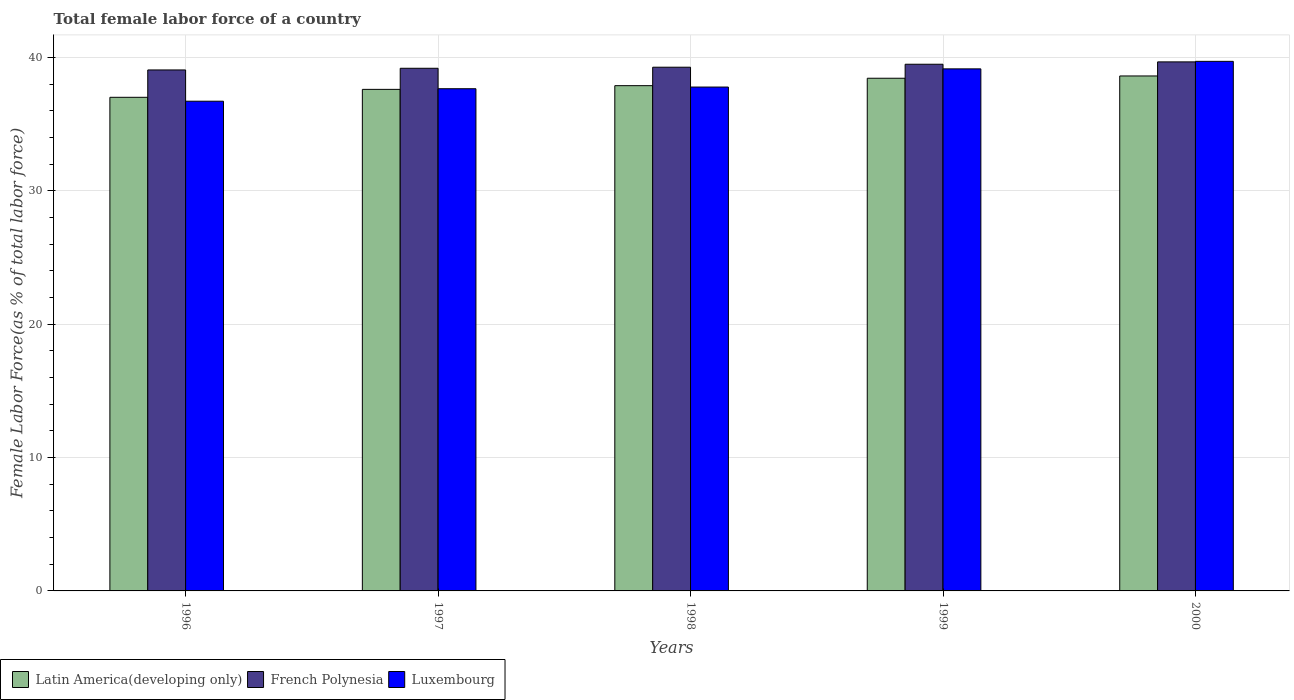How many different coloured bars are there?
Ensure brevity in your answer.  3. Are the number of bars on each tick of the X-axis equal?
Offer a very short reply. Yes. What is the percentage of female labor force in Luxembourg in 1999?
Provide a short and direct response. 39.16. Across all years, what is the maximum percentage of female labor force in French Polynesia?
Ensure brevity in your answer.  39.68. Across all years, what is the minimum percentage of female labor force in French Polynesia?
Your answer should be compact. 39.08. In which year was the percentage of female labor force in Latin America(developing only) minimum?
Offer a terse response. 1996. What is the total percentage of female labor force in French Polynesia in the graph?
Make the answer very short. 196.76. What is the difference between the percentage of female labor force in Latin America(developing only) in 1998 and that in 2000?
Make the answer very short. -0.73. What is the difference between the percentage of female labor force in French Polynesia in 1997 and the percentage of female labor force in Latin America(developing only) in 1999?
Ensure brevity in your answer.  0.75. What is the average percentage of female labor force in Luxembourg per year?
Provide a succinct answer. 38.22. In the year 1999, what is the difference between the percentage of female labor force in French Polynesia and percentage of female labor force in Luxembourg?
Ensure brevity in your answer.  0.35. What is the ratio of the percentage of female labor force in Luxembourg in 1998 to that in 2000?
Your answer should be compact. 0.95. Is the percentage of female labor force in Luxembourg in 1998 less than that in 1999?
Give a very brief answer. Yes. Is the difference between the percentage of female labor force in French Polynesia in 1997 and 1999 greater than the difference between the percentage of female labor force in Luxembourg in 1997 and 1999?
Provide a succinct answer. Yes. What is the difference between the highest and the second highest percentage of female labor force in Luxembourg?
Offer a terse response. 0.56. What is the difference between the highest and the lowest percentage of female labor force in Luxembourg?
Provide a succinct answer. 2.99. In how many years, is the percentage of female labor force in French Polynesia greater than the average percentage of female labor force in French Polynesia taken over all years?
Your response must be concise. 2. Is the sum of the percentage of female labor force in Latin America(developing only) in 1996 and 1998 greater than the maximum percentage of female labor force in French Polynesia across all years?
Your answer should be compact. Yes. What does the 2nd bar from the left in 1996 represents?
Keep it short and to the point. French Polynesia. What does the 3rd bar from the right in 1998 represents?
Make the answer very short. Latin America(developing only). How many bars are there?
Provide a short and direct response. 15. How many years are there in the graph?
Offer a very short reply. 5. Are the values on the major ticks of Y-axis written in scientific E-notation?
Provide a succinct answer. No. How many legend labels are there?
Offer a very short reply. 3. What is the title of the graph?
Give a very brief answer. Total female labor force of a country. Does "Aruba" appear as one of the legend labels in the graph?
Your response must be concise. No. What is the label or title of the X-axis?
Give a very brief answer. Years. What is the label or title of the Y-axis?
Keep it short and to the point. Female Labor Force(as % of total labor force). What is the Female Labor Force(as % of total labor force) of Latin America(developing only) in 1996?
Provide a short and direct response. 37.03. What is the Female Labor Force(as % of total labor force) of French Polynesia in 1996?
Ensure brevity in your answer.  39.08. What is the Female Labor Force(as % of total labor force) in Luxembourg in 1996?
Give a very brief answer. 36.73. What is the Female Labor Force(as % of total labor force) in Latin America(developing only) in 1997?
Ensure brevity in your answer.  37.62. What is the Female Labor Force(as % of total labor force) of French Polynesia in 1997?
Give a very brief answer. 39.2. What is the Female Labor Force(as % of total labor force) of Luxembourg in 1997?
Your answer should be very brief. 37.67. What is the Female Labor Force(as % of total labor force) of Latin America(developing only) in 1998?
Your response must be concise. 37.9. What is the Female Labor Force(as % of total labor force) of French Polynesia in 1998?
Offer a very short reply. 39.28. What is the Female Labor Force(as % of total labor force) in Luxembourg in 1998?
Make the answer very short. 37.8. What is the Female Labor Force(as % of total labor force) in Latin America(developing only) in 1999?
Provide a short and direct response. 38.46. What is the Female Labor Force(as % of total labor force) of French Polynesia in 1999?
Your answer should be compact. 39.51. What is the Female Labor Force(as % of total labor force) of Luxembourg in 1999?
Your answer should be very brief. 39.16. What is the Female Labor Force(as % of total labor force) of Latin America(developing only) in 2000?
Your answer should be very brief. 38.63. What is the Female Labor Force(as % of total labor force) of French Polynesia in 2000?
Provide a short and direct response. 39.68. What is the Female Labor Force(as % of total labor force) of Luxembourg in 2000?
Make the answer very short. 39.72. Across all years, what is the maximum Female Labor Force(as % of total labor force) of Latin America(developing only)?
Offer a terse response. 38.63. Across all years, what is the maximum Female Labor Force(as % of total labor force) in French Polynesia?
Keep it short and to the point. 39.68. Across all years, what is the maximum Female Labor Force(as % of total labor force) of Luxembourg?
Your response must be concise. 39.72. Across all years, what is the minimum Female Labor Force(as % of total labor force) of Latin America(developing only)?
Your response must be concise. 37.03. Across all years, what is the minimum Female Labor Force(as % of total labor force) of French Polynesia?
Offer a terse response. 39.08. Across all years, what is the minimum Female Labor Force(as % of total labor force) of Luxembourg?
Provide a succinct answer. 36.73. What is the total Female Labor Force(as % of total labor force) in Latin America(developing only) in the graph?
Your answer should be compact. 189.63. What is the total Female Labor Force(as % of total labor force) in French Polynesia in the graph?
Provide a short and direct response. 196.76. What is the total Female Labor Force(as % of total labor force) in Luxembourg in the graph?
Keep it short and to the point. 191.08. What is the difference between the Female Labor Force(as % of total labor force) of Latin America(developing only) in 1996 and that in 1997?
Offer a terse response. -0.6. What is the difference between the Female Labor Force(as % of total labor force) of French Polynesia in 1996 and that in 1997?
Provide a short and direct response. -0.13. What is the difference between the Female Labor Force(as % of total labor force) in Luxembourg in 1996 and that in 1997?
Your answer should be compact. -0.94. What is the difference between the Female Labor Force(as % of total labor force) of Latin America(developing only) in 1996 and that in 1998?
Make the answer very short. -0.87. What is the difference between the Female Labor Force(as % of total labor force) of French Polynesia in 1996 and that in 1998?
Offer a very short reply. -0.2. What is the difference between the Female Labor Force(as % of total labor force) of Luxembourg in 1996 and that in 1998?
Ensure brevity in your answer.  -1.06. What is the difference between the Female Labor Force(as % of total labor force) of Latin America(developing only) in 1996 and that in 1999?
Your answer should be very brief. -1.43. What is the difference between the Female Labor Force(as % of total labor force) in French Polynesia in 1996 and that in 1999?
Keep it short and to the point. -0.43. What is the difference between the Female Labor Force(as % of total labor force) in Luxembourg in 1996 and that in 1999?
Your response must be concise. -2.43. What is the difference between the Female Labor Force(as % of total labor force) in Latin America(developing only) in 1996 and that in 2000?
Make the answer very short. -1.6. What is the difference between the Female Labor Force(as % of total labor force) in French Polynesia in 1996 and that in 2000?
Your answer should be compact. -0.61. What is the difference between the Female Labor Force(as % of total labor force) of Luxembourg in 1996 and that in 2000?
Offer a terse response. -2.99. What is the difference between the Female Labor Force(as % of total labor force) of Latin America(developing only) in 1997 and that in 1998?
Give a very brief answer. -0.28. What is the difference between the Female Labor Force(as % of total labor force) in French Polynesia in 1997 and that in 1998?
Your answer should be very brief. -0.08. What is the difference between the Female Labor Force(as % of total labor force) in Luxembourg in 1997 and that in 1998?
Your response must be concise. -0.12. What is the difference between the Female Labor Force(as % of total labor force) of Latin America(developing only) in 1997 and that in 1999?
Your answer should be very brief. -0.83. What is the difference between the Female Labor Force(as % of total labor force) in French Polynesia in 1997 and that in 1999?
Your response must be concise. -0.3. What is the difference between the Female Labor Force(as % of total labor force) in Luxembourg in 1997 and that in 1999?
Keep it short and to the point. -1.49. What is the difference between the Female Labor Force(as % of total labor force) in Latin America(developing only) in 1997 and that in 2000?
Ensure brevity in your answer.  -1.01. What is the difference between the Female Labor Force(as % of total labor force) of French Polynesia in 1997 and that in 2000?
Give a very brief answer. -0.48. What is the difference between the Female Labor Force(as % of total labor force) of Luxembourg in 1997 and that in 2000?
Ensure brevity in your answer.  -2.05. What is the difference between the Female Labor Force(as % of total labor force) of Latin America(developing only) in 1998 and that in 1999?
Offer a very short reply. -0.56. What is the difference between the Female Labor Force(as % of total labor force) of French Polynesia in 1998 and that in 1999?
Give a very brief answer. -0.22. What is the difference between the Female Labor Force(as % of total labor force) of Luxembourg in 1998 and that in 1999?
Your answer should be very brief. -1.36. What is the difference between the Female Labor Force(as % of total labor force) of Latin America(developing only) in 1998 and that in 2000?
Provide a short and direct response. -0.73. What is the difference between the Female Labor Force(as % of total labor force) in French Polynesia in 1998 and that in 2000?
Your answer should be compact. -0.4. What is the difference between the Female Labor Force(as % of total labor force) in Luxembourg in 1998 and that in 2000?
Offer a terse response. -1.93. What is the difference between the Female Labor Force(as % of total labor force) of Latin America(developing only) in 1999 and that in 2000?
Ensure brevity in your answer.  -0.17. What is the difference between the Female Labor Force(as % of total labor force) of French Polynesia in 1999 and that in 2000?
Keep it short and to the point. -0.18. What is the difference between the Female Labor Force(as % of total labor force) of Luxembourg in 1999 and that in 2000?
Give a very brief answer. -0.56. What is the difference between the Female Labor Force(as % of total labor force) in Latin America(developing only) in 1996 and the Female Labor Force(as % of total labor force) in French Polynesia in 1997?
Ensure brevity in your answer.  -2.18. What is the difference between the Female Labor Force(as % of total labor force) in Latin America(developing only) in 1996 and the Female Labor Force(as % of total labor force) in Luxembourg in 1997?
Make the answer very short. -0.64. What is the difference between the Female Labor Force(as % of total labor force) in French Polynesia in 1996 and the Female Labor Force(as % of total labor force) in Luxembourg in 1997?
Provide a succinct answer. 1.41. What is the difference between the Female Labor Force(as % of total labor force) of Latin America(developing only) in 1996 and the Female Labor Force(as % of total labor force) of French Polynesia in 1998?
Keep it short and to the point. -2.26. What is the difference between the Female Labor Force(as % of total labor force) in Latin America(developing only) in 1996 and the Female Labor Force(as % of total labor force) in Luxembourg in 1998?
Offer a terse response. -0.77. What is the difference between the Female Labor Force(as % of total labor force) of French Polynesia in 1996 and the Female Labor Force(as % of total labor force) of Luxembourg in 1998?
Give a very brief answer. 1.28. What is the difference between the Female Labor Force(as % of total labor force) in Latin America(developing only) in 1996 and the Female Labor Force(as % of total labor force) in French Polynesia in 1999?
Keep it short and to the point. -2.48. What is the difference between the Female Labor Force(as % of total labor force) of Latin America(developing only) in 1996 and the Female Labor Force(as % of total labor force) of Luxembourg in 1999?
Offer a terse response. -2.13. What is the difference between the Female Labor Force(as % of total labor force) of French Polynesia in 1996 and the Female Labor Force(as % of total labor force) of Luxembourg in 1999?
Offer a terse response. -0.08. What is the difference between the Female Labor Force(as % of total labor force) in Latin America(developing only) in 1996 and the Female Labor Force(as % of total labor force) in French Polynesia in 2000?
Your response must be concise. -2.66. What is the difference between the Female Labor Force(as % of total labor force) of Latin America(developing only) in 1996 and the Female Labor Force(as % of total labor force) of Luxembourg in 2000?
Your answer should be compact. -2.7. What is the difference between the Female Labor Force(as % of total labor force) in French Polynesia in 1996 and the Female Labor Force(as % of total labor force) in Luxembourg in 2000?
Your response must be concise. -0.64. What is the difference between the Female Labor Force(as % of total labor force) in Latin America(developing only) in 1997 and the Female Labor Force(as % of total labor force) in French Polynesia in 1998?
Make the answer very short. -1.66. What is the difference between the Female Labor Force(as % of total labor force) in Latin America(developing only) in 1997 and the Female Labor Force(as % of total labor force) in Luxembourg in 1998?
Your answer should be compact. -0.17. What is the difference between the Female Labor Force(as % of total labor force) of French Polynesia in 1997 and the Female Labor Force(as % of total labor force) of Luxembourg in 1998?
Keep it short and to the point. 1.41. What is the difference between the Female Labor Force(as % of total labor force) in Latin America(developing only) in 1997 and the Female Labor Force(as % of total labor force) in French Polynesia in 1999?
Give a very brief answer. -1.88. What is the difference between the Female Labor Force(as % of total labor force) of Latin America(developing only) in 1997 and the Female Labor Force(as % of total labor force) of Luxembourg in 1999?
Your response must be concise. -1.54. What is the difference between the Female Labor Force(as % of total labor force) of French Polynesia in 1997 and the Female Labor Force(as % of total labor force) of Luxembourg in 1999?
Provide a succinct answer. 0.05. What is the difference between the Female Labor Force(as % of total labor force) in Latin America(developing only) in 1997 and the Female Labor Force(as % of total labor force) in French Polynesia in 2000?
Make the answer very short. -2.06. What is the difference between the Female Labor Force(as % of total labor force) of Latin America(developing only) in 1997 and the Female Labor Force(as % of total labor force) of Luxembourg in 2000?
Your response must be concise. -2.1. What is the difference between the Female Labor Force(as % of total labor force) of French Polynesia in 1997 and the Female Labor Force(as % of total labor force) of Luxembourg in 2000?
Your response must be concise. -0.52. What is the difference between the Female Labor Force(as % of total labor force) of Latin America(developing only) in 1998 and the Female Labor Force(as % of total labor force) of French Polynesia in 1999?
Ensure brevity in your answer.  -1.61. What is the difference between the Female Labor Force(as % of total labor force) in Latin America(developing only) in 1998 and the Female Labor Force(as % of total labor force) in Luxembourg in 1999?
Give a very brief answer. -1.26. What is the difference between the Female Labor Force(as % of total labor force) of French Polynesia in 1998 and the Female Labor Force(as % of total labor force) of Luxembourg in 1999?
Offer a very short reply. 0.12. What is the difference between the Female Labor Force(as % of total labor force) in Latin America(developing only) in 1998 and the Female Labor Force(as % of total labor force) in French Polynesia in 2000?
Your response must be concise. -1.78. What is the difference between the Female Labor Force(as % of total labor force) of Latin America(developing only) in 1998 and the Female Labor Force(as % of total labor force) of Luxembourg in 2000?
Offer a terse response. -1.82. What is the difference between the Female Labor Force(as % of total labor force) of French Polynesia in 1998 and the Female Labor Force(as % of total labor force) of Luxembourg in 2000?
Your answer should be compact. -0.44. What is the difference between the Female Labor Force(as % of total labor force) of Latin America(developing only) in 1999 and the Female Labor Force(as % of total labor force) of French Polynesia in 2000?
Offer a terse response. -1.23. What is the difference between the Female Labor Force(as % of total labor force) in Latin America(developing only) in 1999 and the Female Labor Force(as % of total labor force) in Luxembourg in 2000?
Offer a terse response. -1.27. What is the difference between the Female Labor Force(as % of total labor force) of French Polynesia in 1999 and the Female Labor Force(as % of total labor force) of Luxembourg in 2000?
Provide a succinct answer. -0.22. What is the average Female Labor Force(as % of total labor force) of Latin America(developing only) per year?
Make the answer very short. 37.93. What is the average Female Labor Force(as % of total labor force) in French Polynesia per year?
Give a very brief answer. 39.35. What is the average Female Labor Force(as % of total labor force) of Luxembourg per year?
Offer a very short reply. 38.22. In the year 1996, what is the difference between the Female Labor Force(as % of total labor force) in Latin America(developing only) and Female Labor Force(as % of total labor force) in French Polynesia?
Provide a short and direct response. -2.05. In the year 1996, what is the difference between the Female Labor Force(as % of total labor force) in Latin America(developing only) and Female Labor Force(as % of total labor force) in Luxembourg?
Make the answer very short. 0.29. In the year 1996, what is the difference between the Female Labor Force(as % of total labor force) of French Polynesia and Female Labor Force(as % of total labor force) of Luxembourg?
Provide a succinct answer. 2.35. In the year 1997, what is the difference between the Female Labor Force(as % of total labor force) of Latin America(developing only) and Female Labor Force(as % of total labor force) of French Polynesia?
Ensure brevity in your answer.  -1.58. In the year 1997, what is the difference between the Female Labor Force(as % of total labor force) of Latin America(developing only) and Female Labor Force(as % of total labor force) of Luxembourg?
Give a very brief answer. -0.05. In the year 1997, what is the difference between the Female Labor Force(as % of total labor force) in French Polynesia and Female Labor Force(as % of total labor force) in Luxembourg?
Make the answer very short. 1.53. In the year 1998, what is the difference between the Female Labor Force(as % of total labor force) of Latin America(developing only) and Female Labor Force(as % of total labor force) of French Polynesia?
Provide a succinct answer. -1.38. In the year 1998, what is the difference between the Female Labor Force(as % of total labor force) in Latin America(developing only) and Female Labor Force(as % of total labor force) in Luxembourg?
Ensure brevity in your answer.  0.1. In the year 1998, what is the difference between the Female Labor Force(as % of total labor force) in French Polynesia and Female Labor Force(as % of total labor force) in Luxembourg?
Your response must be concise. 1.49. In the year 1999, what is the difference between the Female Labor Force(as % of total labor force) in Latin America(developing only) and Female Labor Force(as % of total labor force) in French Polynesia?
Keep it short and to the point. -1.05. In the year 1999, what is the difference between the Female Labor Force(as % of total labor force) in Latin America(developing only) and Female Labor Force(as % of total labor force) in Luxembourg?
Your answer should be compact. -0.7. In the year 1999, what is the difference between the Female Labor Force(as % of total labor force) in French Polynesia and Female Labor Force(as % of total labor force) in Luxembourg?
Your answer should be very brief. 0.35. In the year 2000, what is the difference between the Female Labor Force(as % of total labor force) of Latin America(developing only) and Female Labor Force(as % of total labor force) of French Polynesia?
Make the answer very short. -1.06. In the year 2000, what is the difference between the Female Labor Force(as % of total labor force) in Latin America(developing only) and Female Labor Force(as % of total labor force) in Luxembourg?
Offer a terse response. -1.1. In the year 2000, what is the difference between the Female Labor Force(as % of total labor force) in French Polynesia and Female Labor Force(as % of total labor force) in Luxembourg?
Your answer should be very brief. -0.04. What is the ratio of the Female Labor Force(as % of total labor force) in Latin America(developing only) in 1996 to that in 1997?
Keep it short and to the point. 0.98. What is the ratio of the Female Labor Force(as % of total labor force) of Luxembourg in 1996 to that in 1997?
Keep it short and to the point. 0.98. What is the ratio of the Female Labor Force(as % of total labor force) of Latin America(developing only) in 1996 to that in 1998?
Your answer should be compact. 0.98. What is the ratio of the Female Labor Force(as % of total labor force) of Luxembourg in 1996 to that in 1998?
Your response must be concise. 0.97. What is the ratio of the Female Labor Force(as % of total labor force) of Latin America(developing only) in 1996 to that in 1999?
Offer a very short reply. 0.96. What is the ratio of the Female Labor Force(as % of total labor force) of French Polynesia in 1996 to that in 1999?
Ensure brevity in your answer.  0.99. What is the ratio of the Female Labor Force(as % of total labor force) of Luxembourg in 1996 to that in 1999?
Offer a very short reply. 0.94. What is the ratio of the Female Labor Force(as % of total labor force) of Latin America(developing only) in 1996 to that in 2000?
Provide a succinct answer. 0.96. What is the ratio of the Female Labor Force(as % of total labor force) in Luxembourg in 1996 to that in 2000?
Offer a very short reply. 0.92. What is the ratio of the Female Labor Force(as % of total labor force) of Latin America(developing only) in 1997 to that in 1998?
Keep it short and to the point. 0.99. What is the ratio of the Female Labor Force(as % of total labor force) in Latin America(developing only) in 1997 to that in 1999?
Your answer should be compact. 0.98. What is the ratio of the Female Labor Force(as % of total labor force) in Luxembourg in 1997 to that in 1999?
Offer a very short reply. 0.96. What is the ratio of the Female Labor Force(as % of total labor force) of Latin America(developing only) in 1997 to that in 2000?
Offer a terse response. 0.97. What is the ratio of the Female Labor Force(as % of total labor force) of French Polynesia in 1997 to that in 2000?
Your answer should be very brief. 0.99. What is the ratio of the Female Labor Force(as % of total labor force) of Luxembourg in 1997 to that in 2000?
Give a very brief answer. 0.95. What is the ratio of the Female Labor Force(as % of total labor force) in Latin America(developing only) in 1998 to that in 1999?
Ensure brevity in your answer.  0.99. What is the ratio of the Female Labor Force(as % of total labor force) in Luxembourg in 1998 to that in 1999?
Your answer should be compact. 0.97. What is the ratio of the Female Labor Force(as % of total labor force) in Latin America(developing only) in 1998 to that in 2000?
Offer a very short reply. 0.98. What is the ratio of the Female Labor Force(as % of total labor force) of French Polynesia in 1998 to that in 2000?
Offer a very short reply. 0.99. What is the ratio of the Female Labor Force(as % of total labor force) of Luxembourg in 1998 to that in 2000?
Give a very brief answer. 0.95. What is the ratio of the Female Labor Force(as % of total labor force) of French Polynesia in 1999 to that in 2000?
Give a very brief answer. 1. What is the ratio of the Female Labor Force(as % of total labor force) of Luxembourg in 1999 to that in 2000?
Offer a terse response. 0.99. What is the difference between the highest and the second highest Female Labor Force(as % of total labor force) in Latin America(developing only)?
Give a very brief answer. 0.17. What is the difference between the highest and the second highest Female Labor Force(as % of total labor force) in French Polynesia?
Offer a terse response. 0.18. What is the difference between the highest and the second highest Female Labor Force(as % of total labor force) of Luxembourg?
Provide a short and direct response. 0.56. What is the difference between the highest and the lowest Female Labor Force(as % of total labor force) in Latin America(developing only)?
Your answer should be very brief. 1.6. What is the difference between the highest and the lowest Female Labor Force(as % of total labor force) of French Polynesia?
Give a very brief answer. 0.61. What is the difference between the highest and the lowest Female Labor Force(as % of total labor force) in Luxembourg?
Provide a short and direct response. 2.99. 